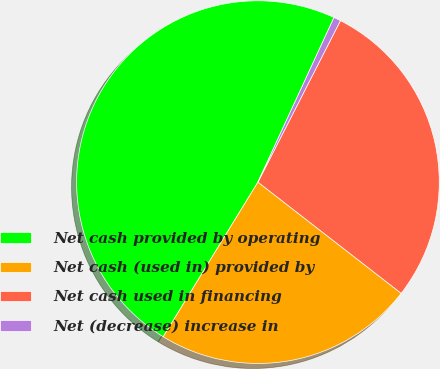Convert chart. <chart><loc_0><loc_0><loc_500><loc_500><pie_chart><fcel>Net cash provided by operating<fcel>Net cash (used in) provided by<fcel>Net cash used in financing<fcel>Net (decrease) increase in<nl><fcel>48.15%<fcel>23.24%<fcel>27.99%<fcel>0.63%<nl></chart> 